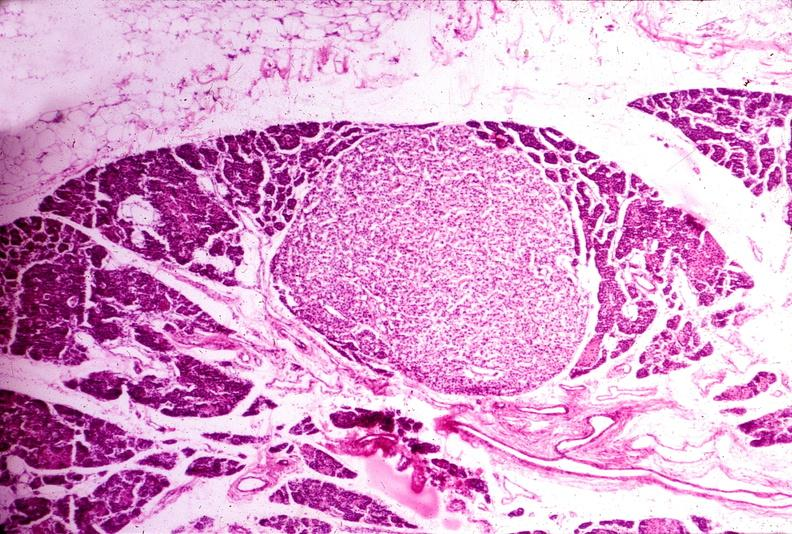what is present?
Answer the question using a single word or phrase. Endocrine 